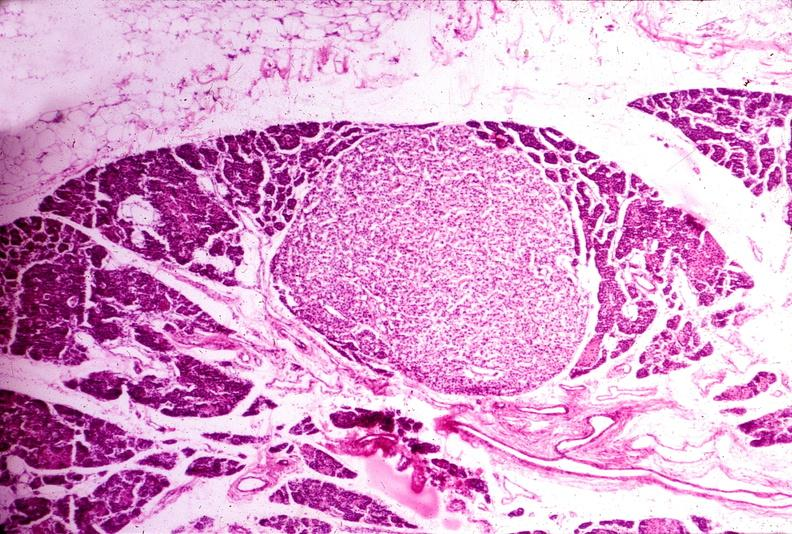what is present?
Answer the question using a single word or phrase. Endocrine 